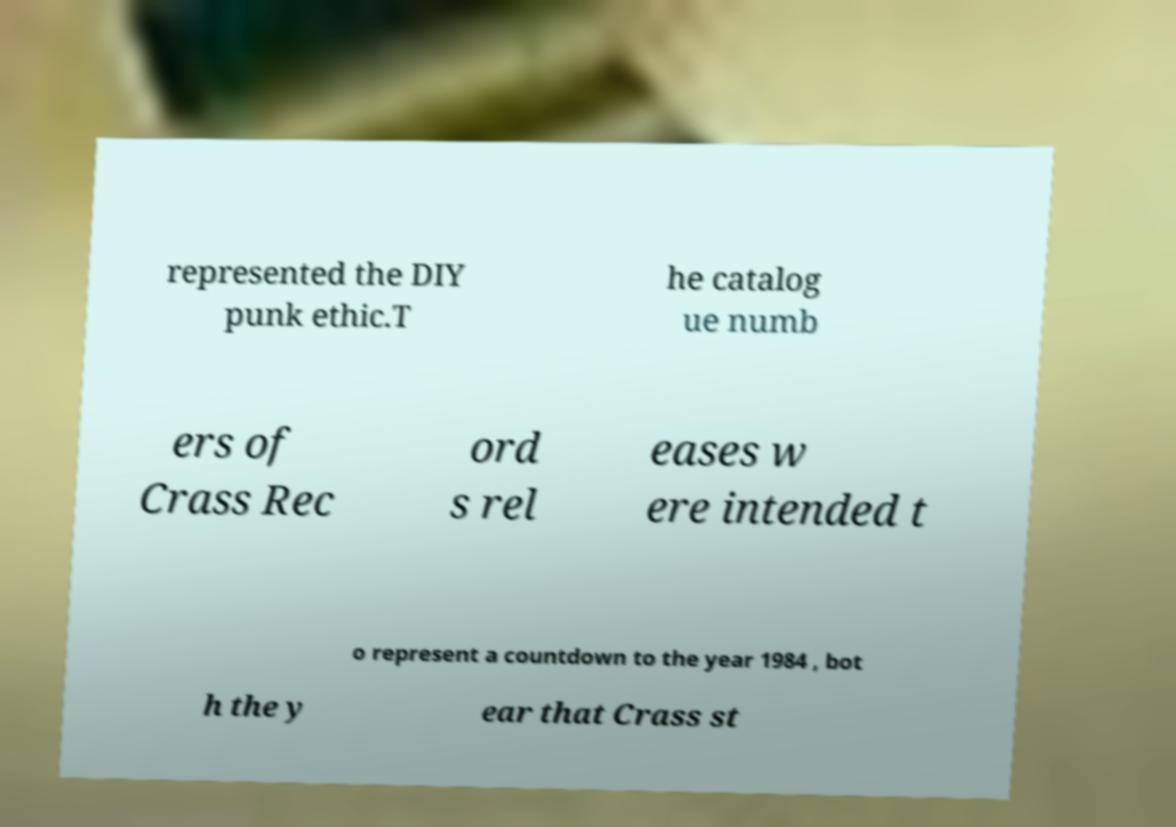Please identify and transcribe the text found in this image. represented the DIY punk ethic.T he catalog ue numb ers of Crass Rec ord s rel eases w ere intended t o represent a countdown to the year 1984 , bot h the y ear that Crass st 